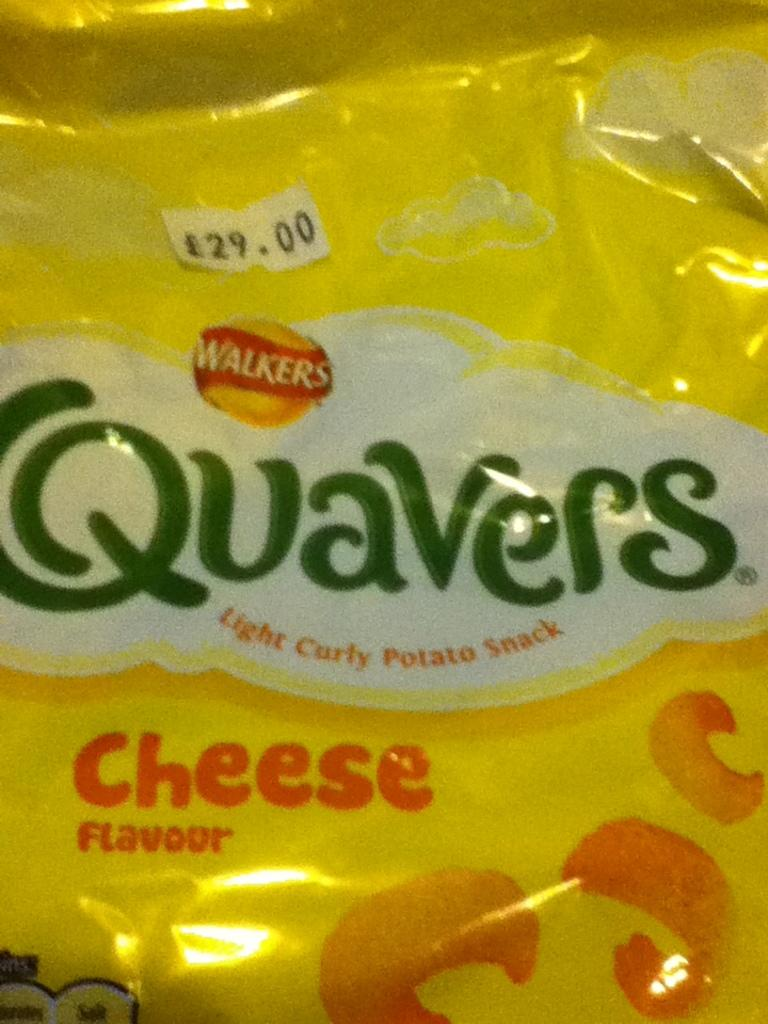What is present in the image? There is a packet in the image. What can be found inside the packet? The packet contains text. What type of brass instrument is being played on the desk in the image? There is no brass instrument or desk present in the image; it only contains a packet with text. 